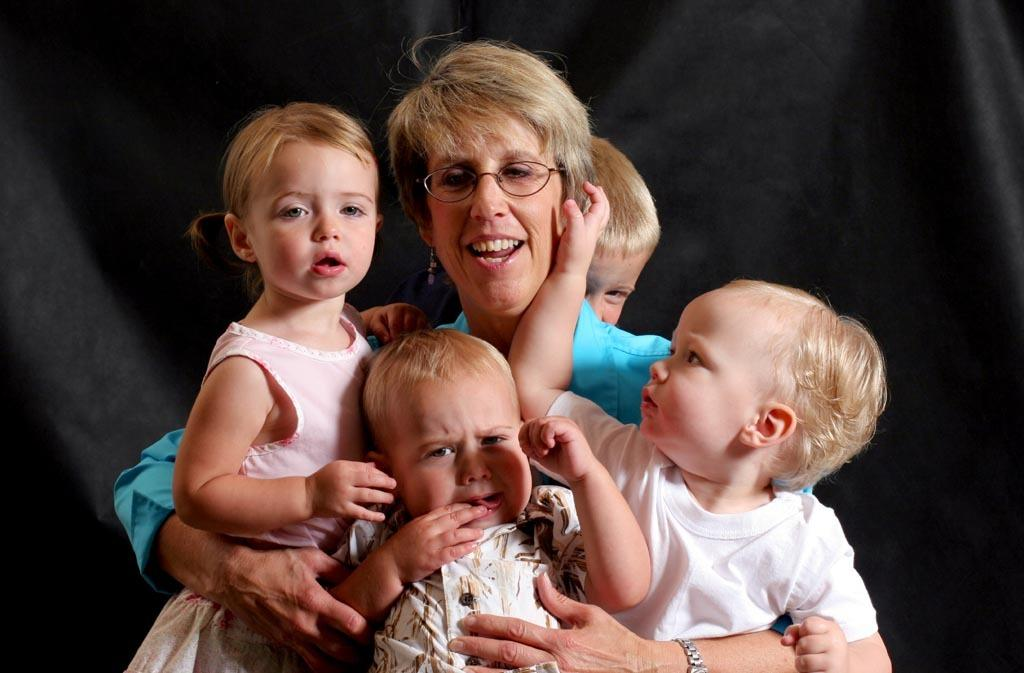Who is the main subject in the image? There is a woman in the image. What is the woman wearing? The woman is wearing a blue t-shirt. What is the woman doing in the image? The woman is holding three babies and smiling. Are there any other babies in the image? Yes, there is another baby behind the woman. What is the color of the background in the image? The background of the image is dark in color. Can you see any steps in the image? There are no steps visible in the image. Is there any water present in the image? There is no water present in the image. 